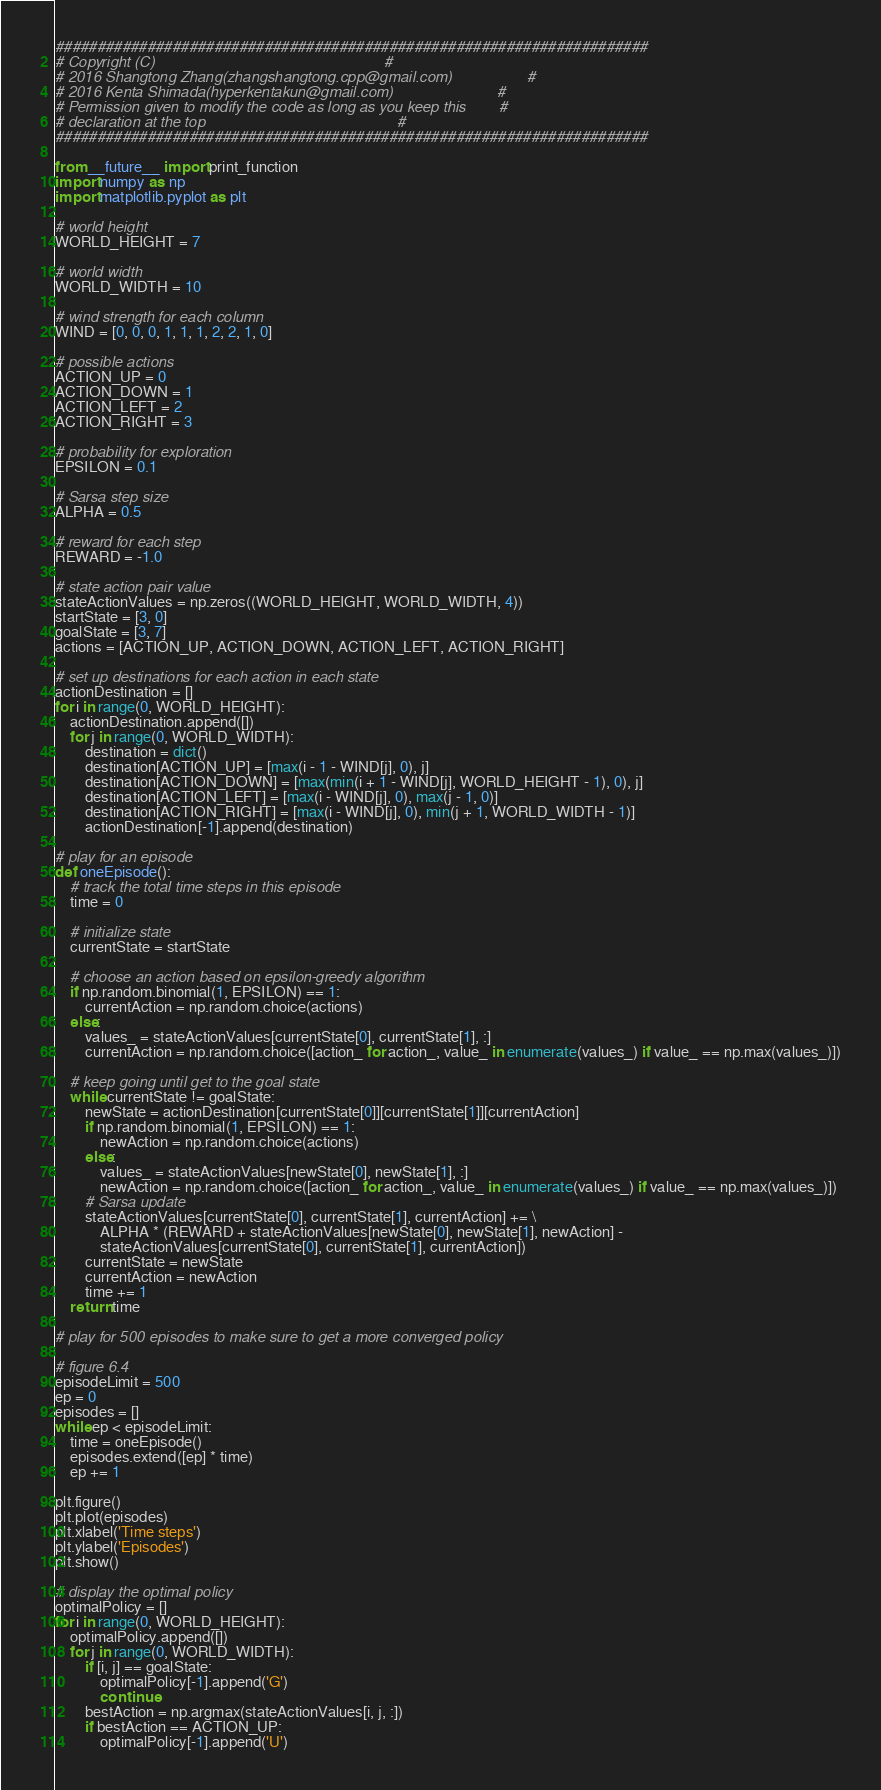Convert code to text. <code><loc_0><loc_0><loc_500><loc_500><_Python_>#######################################################################
# Copyright (C)                                                       #
# 2016 Shangtong Zhang(zhangshangtong.cpp@gmail.com)                  #
# 2016 Kenta Shimada(hyperkentakun@gmail.com)                         #
# Permission given to modify the code as long as you keep this        #
# declaration at the top                                              #
#######################################################################

from __future__ import print_function
import numpy as np
import matplotlib.pyplot as plt

# world height
WORLD_HEIGHT = 7

# world width
WORLD_WIDTH = 10

# wind strength for each column
WIND = [0, 0, 0, 1, 1, 1, 2, 2, 1, 0]

# possible actions
ACTION_UP = 0
ACTION_DOWN = 1
ACTION_LEFT = 2
ACTION_RIGHT = 3

# probability for exploration
EPSILON = 0.1

# Sarsa step size
ALPHA = 0.5

# reward for each step
REWARD = -1.0

# state action pair value
stateActionValues = np.zeros((WORLD_HEIGHT, WORLD_WIDTH, 4))
startState = [3, 0]
goalState = [3, 7]
actions = [ACTION_UP, ACTION_DOWN, ACTION_LEFT, ACTION_RIGHT]

# set up destinations for each action in each state
actionDestination = []
for i in range(0, WORLD_HEIGHT):
    actionDestination.append([])
    for j in range(0, WORLD_WIDTH):
        destination = dict()
        destination[ACTION_UP] = [max(i - 1 - WIND[j], 0), j]
        destination[ACTION_DOWN] = [max(min(i + 1 - WIND[j], WORLD_HEIGHT - 1), 0), j]
        destination[ACTION_LEFT] = [max(i - WIND[j], 0), max(j - 1, 0)]
        destination[ACTION_RIGHT] = [max(i - WIND[j], 0), min(j + 1, WORLD_WIDTH - 1)]
        actionDestination[-1].append(destination)

# play for an episode
def oneEpisode():
    # track the total time steps in this episode
    time = 0

    # initialize state
    currentState = startState

    # choose an action based on epsilon-greedy algorithm
    if np.random.binomial(1, EPSILON) == 1:
        currentAction = np.random.choice(actions)
    else:
        values_ = stateActionValues[currentState[0], currentState[1], :]
        currentAction = np.random.choice([action_ for action_, value_ in enumerate(values_) if value_ == np.max(values_)])

    # keep going until get to the goal state
    while currentState != goalState:
        newState = actionDestination[currentState[0]][currentState[1]][currentAction]
        if np.random.binomial(1, EPSILON) == 1:
            newAction = np.random.choice(actions)
        else:
            values_ = stateActionValues[newState[0], newState[1], :]
            newAction = np.random.choice([action_ for action_, value_ in enumerate(values_) if value_ == np.max(values_)])
        # Sarsa update
        stateActionValues[currentState[0], currentState[1], currentAction] += \
            ALPHA * (REWARD + stateActionValues[newState[0], newState[1], newAction] -
            stateActionValues[currentState[0], currentState[1], currentAction])
        currentState = newState
        currentAction = newAction
        time += 1
    return time

# play for 500 episodes to make sure to get a more converged policy

# figure 6.4
episodeLimit = 500
ep = 0
episodes = []
while ep < episodeLimit:
    time = oneEpisode()
    episodes.extend([ep] * time)
    ep += 1

plt.figure()
plt.plot(episodes)
plt.xlabel('Time steps')
plt.ylabel('Episodes')
plt.show()

# display the optimal policy
optimalPolicy = []
for i in range(0, WORLD_HEIGHT):
    optimalPolicy.append([])
    for j in range(0, WORLD_WIDTH):
        if [i, j] == goalState:
            optimalPolicy[-1].append('G')
            continue
        bestAction = np.argmax(stateActionValues[i, j, :])
        if bestAction == ACTION_UP:
            optimalPolicy[-1].append('U')</code> 